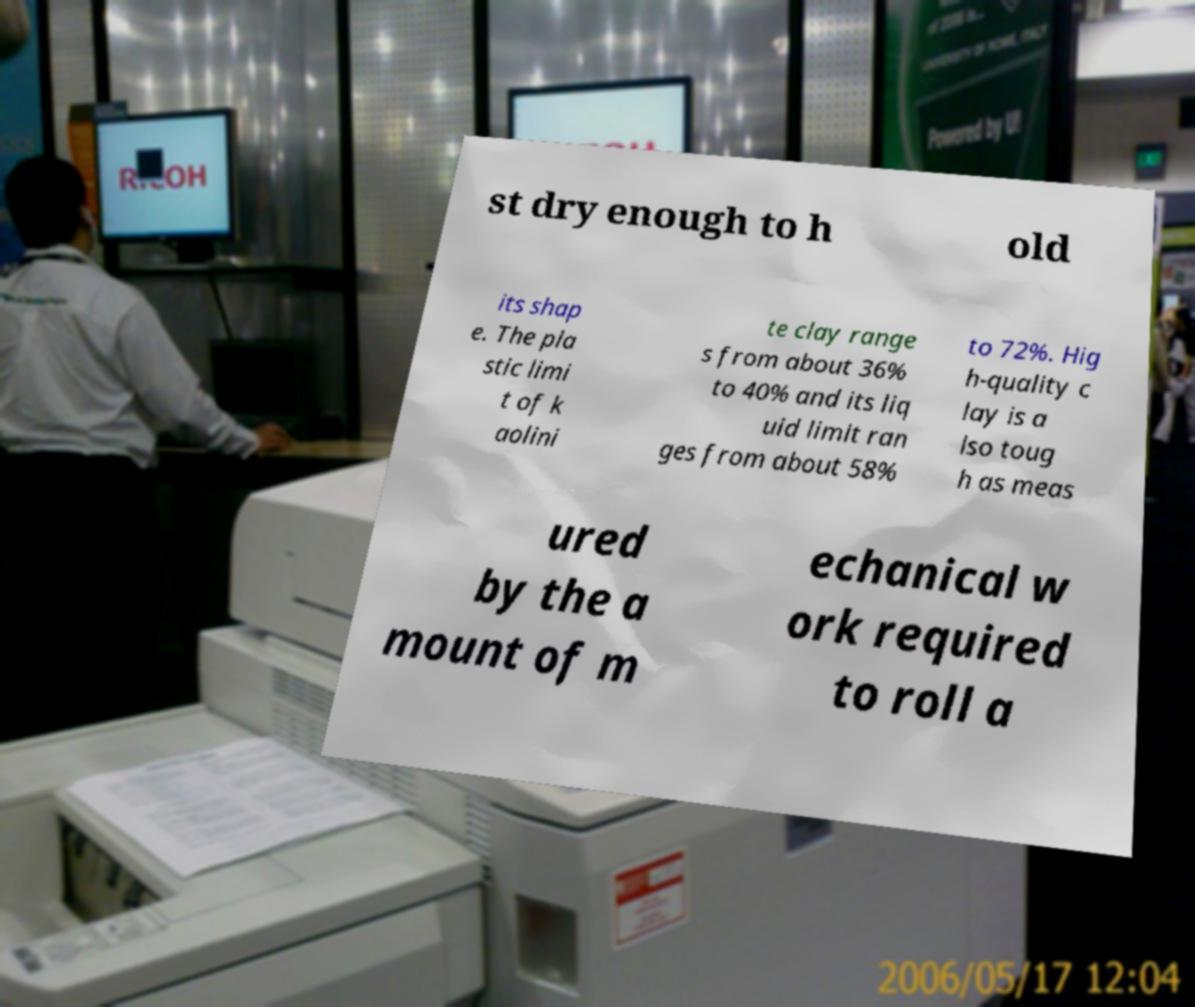Can you read and provide the text displayed in the image?This photo seems to have some interesting text. Can you extract and type it out for me? st dry enough to h old its shap e. The pla stic limi t of k aolini te clay range s from about 36% to 40% and its liq uid limit ran ges from about 58% to 72%. Hig h-quality c lay is a lso toug h as meas ured by the a mount of m echanical w ork required to roll a 